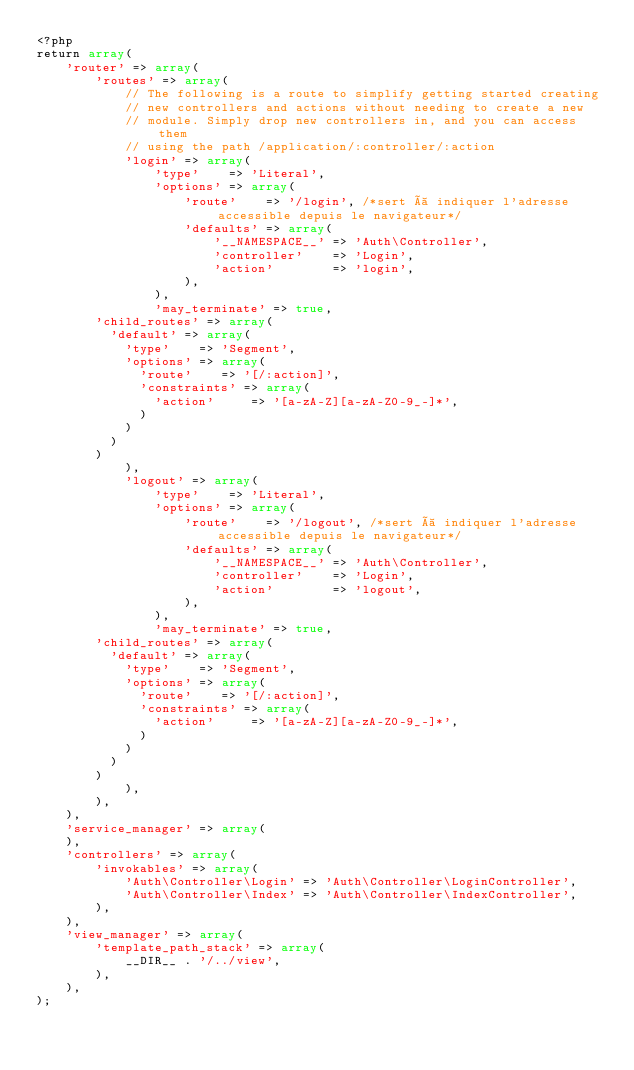Convert code to text. <code><loc_0><loc_0><loc_500><loc_500><_PHP_><?php
return array(
    'router' => array(
        'routes' => array(
            // The following is a route to simplify getting started creating
            // new controllers and actions without needing to create a new
            // module. Simply drop new controllers in, and you can access them
            // using the path /application/:controller/:action
            'login' => array(
                'type'    => 'Literal',
                'options' => array(
                    'route'    => '/login', /*sert à indiquer l'adresse accessible depuis le navigateur*/
                    'defaults' => array(
                        '__NAMESPACE__' => 'Auth\Controller',
                        'controller'    => 'Login',
                        'action'        => 'login',
                    ),
                ),
                'may_terminate' => true,
				'child_routes' => array(
					'default' => array(
						'type'    => 'Segment',
						'options' => array(
							'route'    => '[/:action]',
							'constraints' => array(
								'action'     => '[a-zA-Z][a-zA-Z0-9_-]*',
							)
						)
					)
				)
            ),
            'logout' => array(
                'type'    => 'Literal',
                'options' => array(
                    'route'    => '/logout', /*sert à indiquer l'adresse accessible depuis le navigateur*/
                    'defaults' => array(
                        '__NAMESPACE__' => 'Auth\Controller',
                        'controller'    => 'Login',
                        'action'        => 'logout',
                    ),
                ),
                'may_terminate' => true,
				'child_routes' => array(
					'default' => array(
						'type'    => 'Segment',
						'options' => array(
							'route'    => '[/:action]',
							'constraints' => array(
								'action'     => '[a-zA-Z][a-zA-Z0-9_-]*',
							)
						)
					)
				)
            ),
        ),
    ),
    'service_manager' => array(
    ),
    'controllers' => array(
        'invokables' => array(
            'Auth\Controller\Login' => 'Auth\Controller\LoginController',
            'Auth\Controller\Index' => 'Auth\Controller\IndexController',
        ),
    ),
    'view_manager' => array(
        'template_path_stack' => array(
            __DIR__ . '/../view',
        ),
    ),
);</code> 